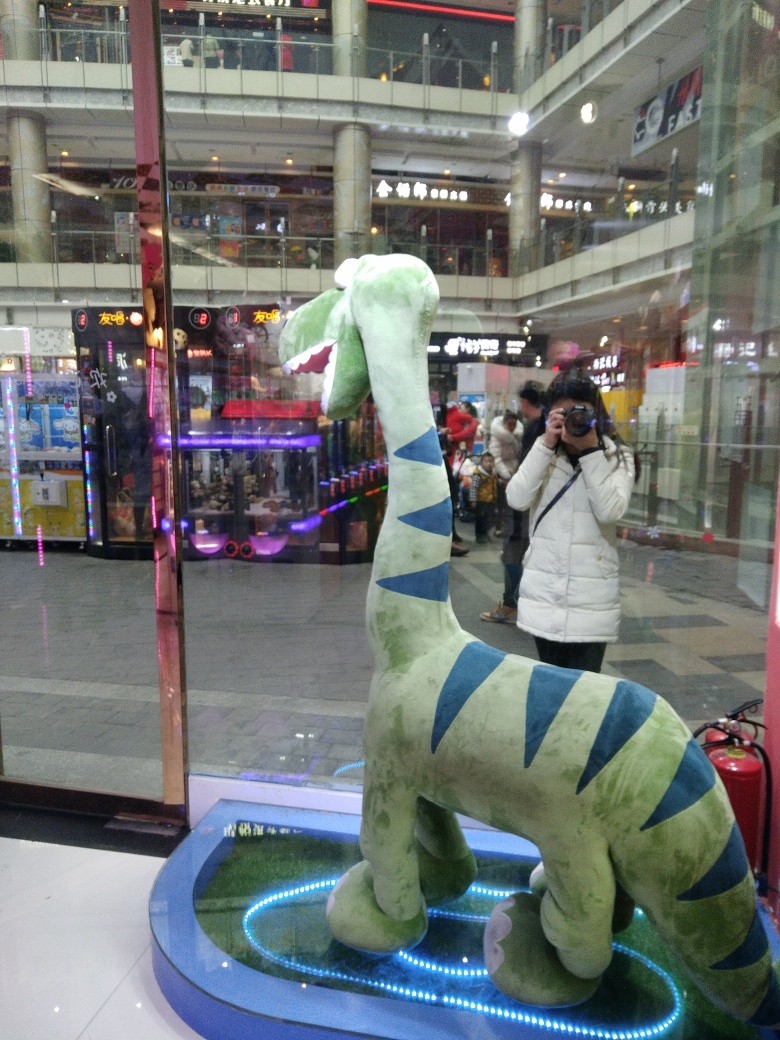How would you describe the composition of the image? A. mediocre, with an unclear subject B. bad, with an obscure subject C. good, with a prominent subject D. excellent, with an insignificant subject Answer with the option's letter from the given choices directly. The image composition showcases a playful, vibrant moment, with a plush dinosaur model as a clear subject set against a busy indoor arcade environment. The subject is well-framed and serves as a focal point, but the photo also captures the reflection of a photographer, which adds a layer of narrative and depth to the image. The overall aesthetic might not be 'excellent' due to visible distractions and typical indoor lighting, but the composition does a solid job of capturing a spontaneous moment with a touch of whimsy. Choosing from the provided options, the apt description would be 'C. good, with a prominent subject.' 